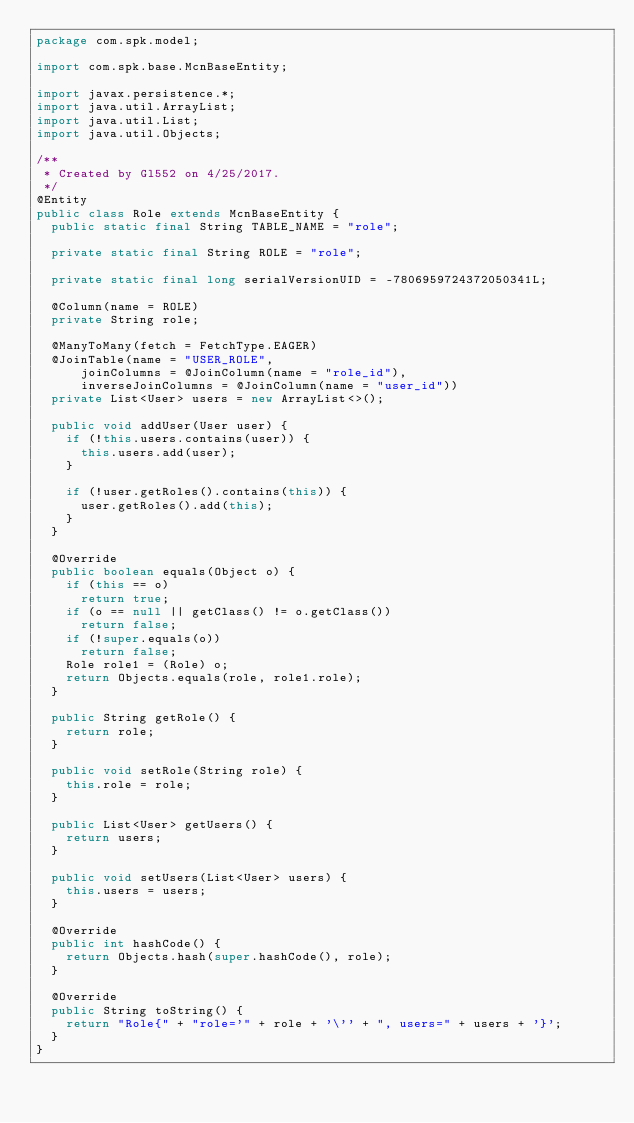Convert code to text. <code><loc_0><loc_0><loc_500><loc_500><_Java_>package com.spk.model;

import com.spk.base.McnBaseEntity;

import javax.persistence.*;
import java.util.ArrayList;
import java.util.List;
import java.util.Objects;

/**
 * Created by Gl552 on 4/25/2017.
 */
@Entity
public class Role extends McnBaseEntity {
  public static final String TABLE_NAME = "role";

  private static final String ROLE = "role";

  private static final long serialVersionUID = -7806959724372050341L;

  @Column(name = ROLE)
  private String role;

  @ManyToMany(fetch = FetchType.EAGER)
  @JoinTable(name = "USER_ROLE",
      joinColumns = @JoinColumn(name = "role_id"),
      inverseJoinColumns = @JoinColumn(name = "user_id"))
  private List<User> users = new ArrayList<>();

  public void addUser(User user) {
    if (!this.users.contains(user)) {
      this.users.add(user);
    }

    if (!user.getRoles().contains(this)) {
      user.getRoles().add(this);
    }
  }

  @Override
  public boolean equals(Object o) {
    if (this == o)
      return true;
    if (o == null || getClass() != o.getClass())
      return false;
    if (!super.equals(o))
      return false;
    Role role1 = (Role) o;
    return Objects.equals(role, role1.role);
  }

  public String getRole() {
    return role;
  }

  public void setRole(String role) {
    this.role = role;
  }

  public List<User> getUsers() {
    return users;
  }

  public void setUsers(List<User> users) {
    this.users = users;
  }

  @Override
  public int hashCode() {
    return Objects.hash(super.hashCode(), role);
  }

  @Override
  public String toString() {
    return "Role{" + "role='" + role + '\'' + ", users=" + users + '}';
  }
}
</code> 